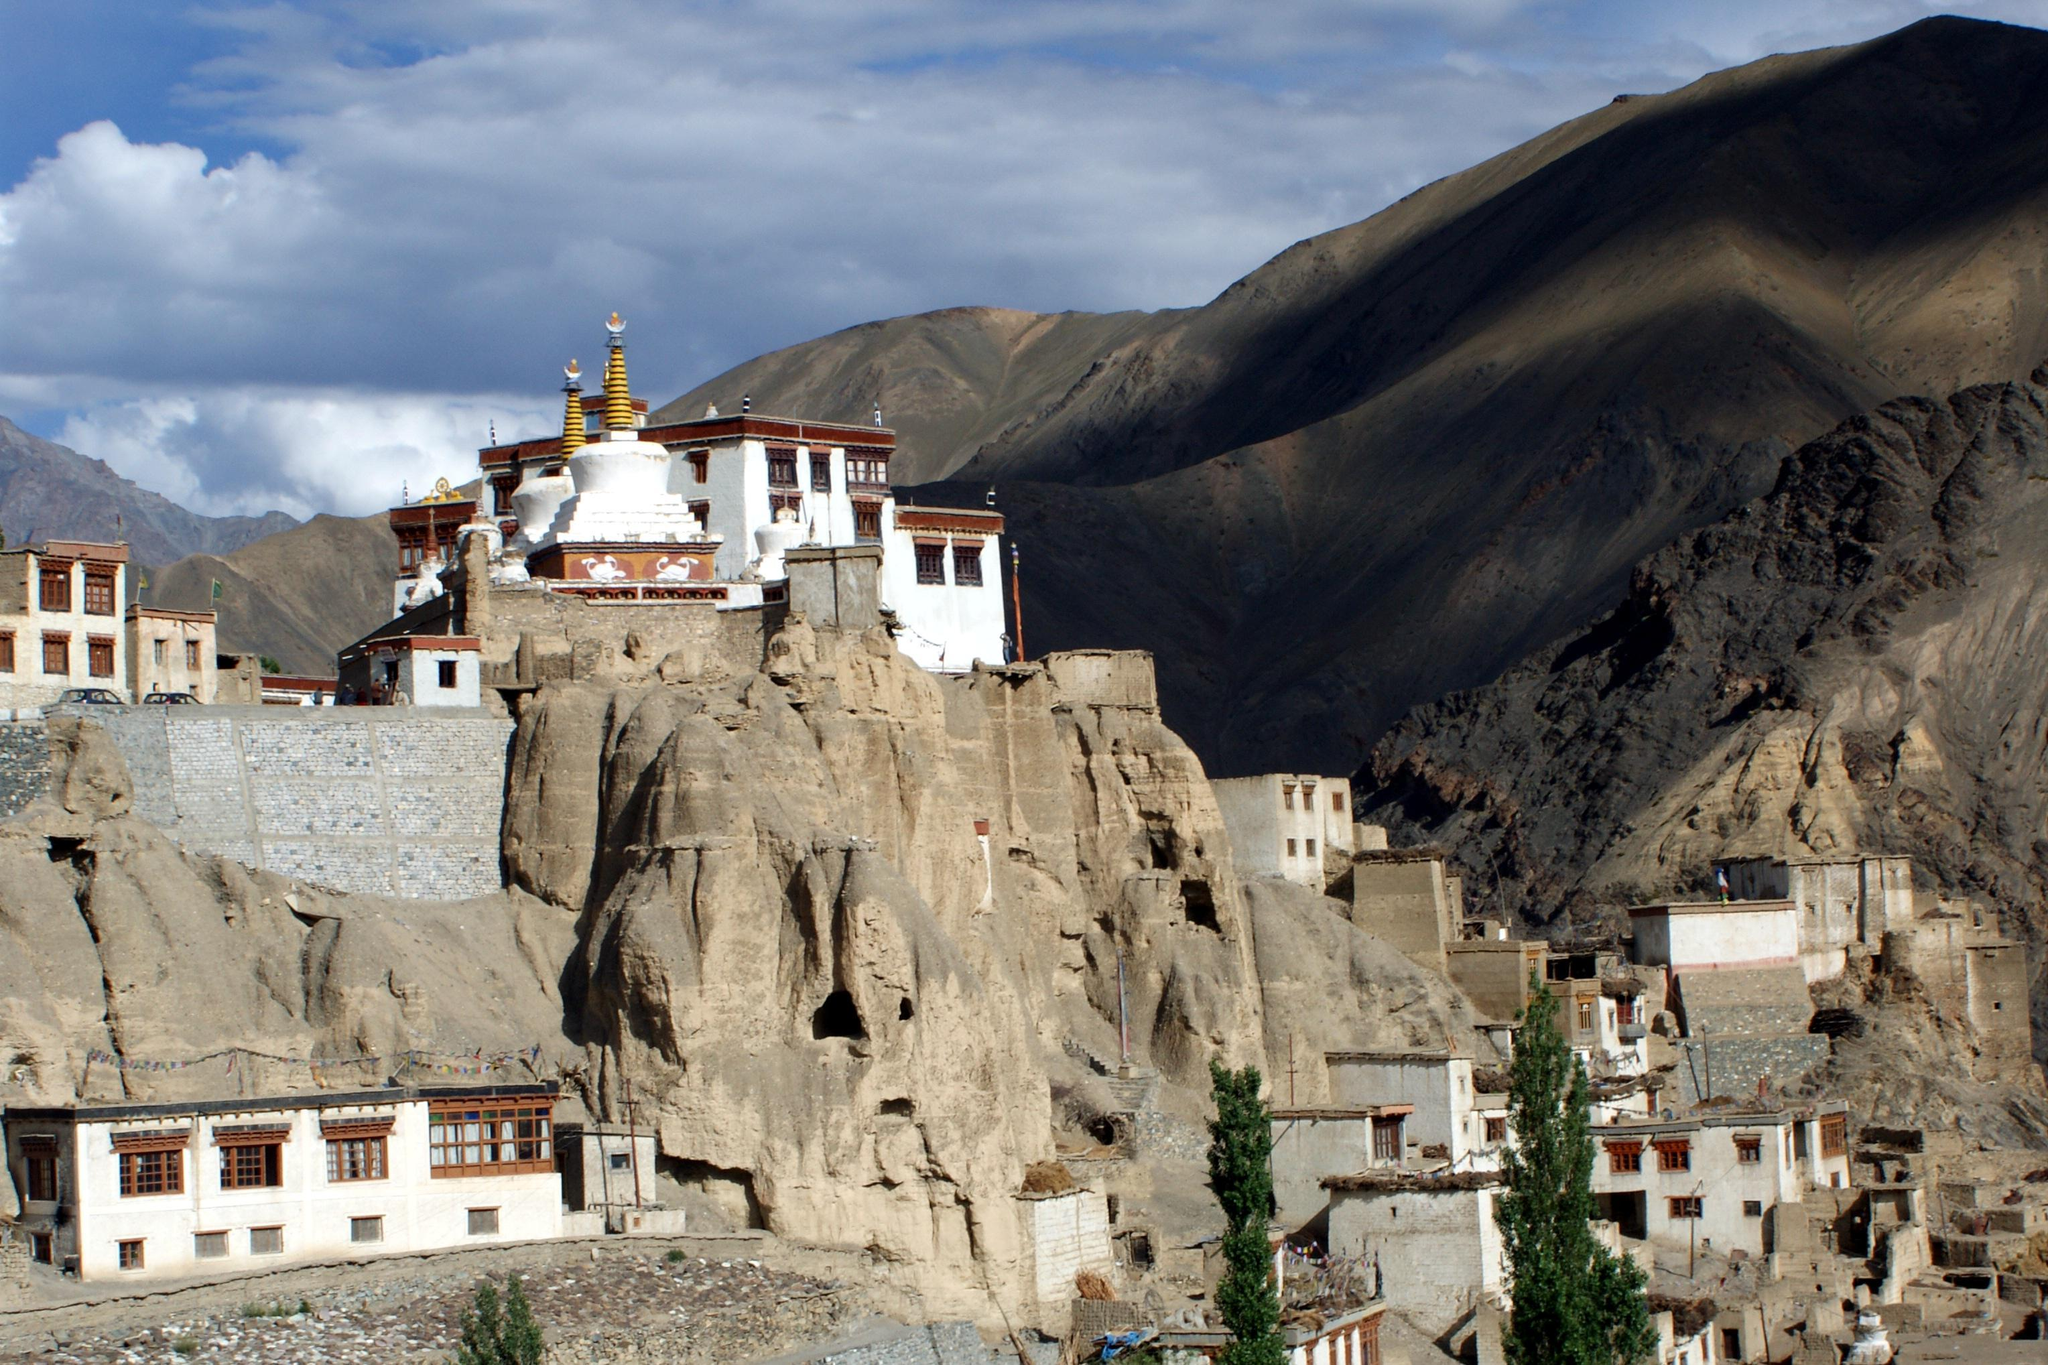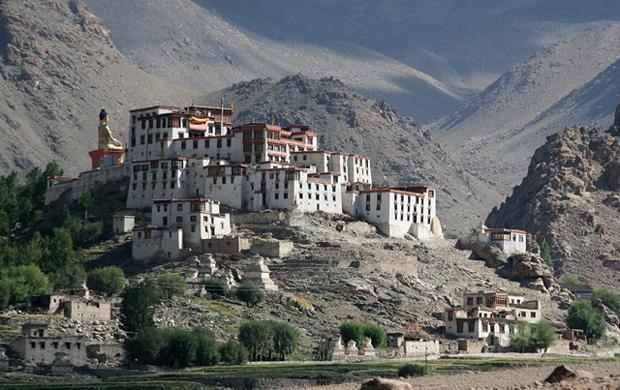The first image is the image on the left, the second image is the image on the right. Assess this claim about the two images: "A large golden shrine in the image of a person can be seen in both images.". Correct or not? Answer yes or no. No. The first image is the image on the left, the second image is the image on the right. Assess this claim about the two images: "An image includes a golden seated figure with blue hair.". Correct or not? Answer yes or no. No. 